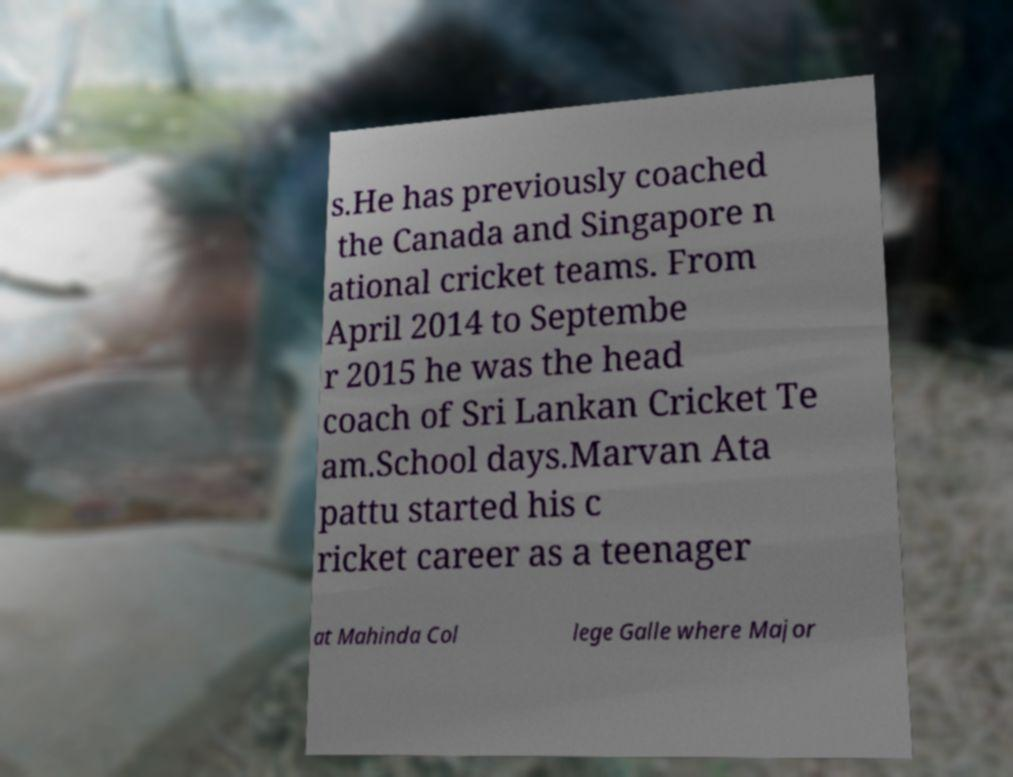Please read and relay the text visible in this image. What does it say? s.He has previously coached the Canada and Singapore n ational cricket teams. From April 2014 to Septembe r 2015 he was the head coach of Sri Lankan Cricket Te am.School days.Marvan Ata pattu started his c ricket career as a teenager at Mahinda Col lege Galle where Major 